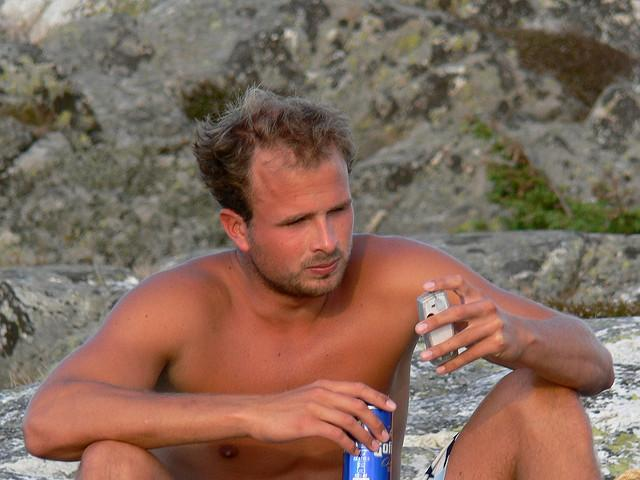What is the man holding?

Choices:
A) baby
B) apple
C) can
D) kitten can 